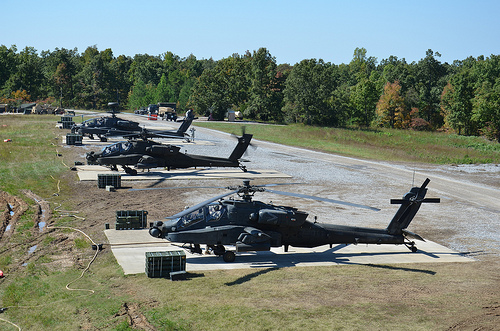<image>
Is the propeller on the helicopter? No. The propeller is not positioned on the helicopter. They may be near each other, but the propeller is not supported by or resting on top of the helicopter. Is the helicopter on the tree? No. The helicopter is not positioned on the tree. They may be near each other, but the helicopter is not supported by or resting on top of the tree. 